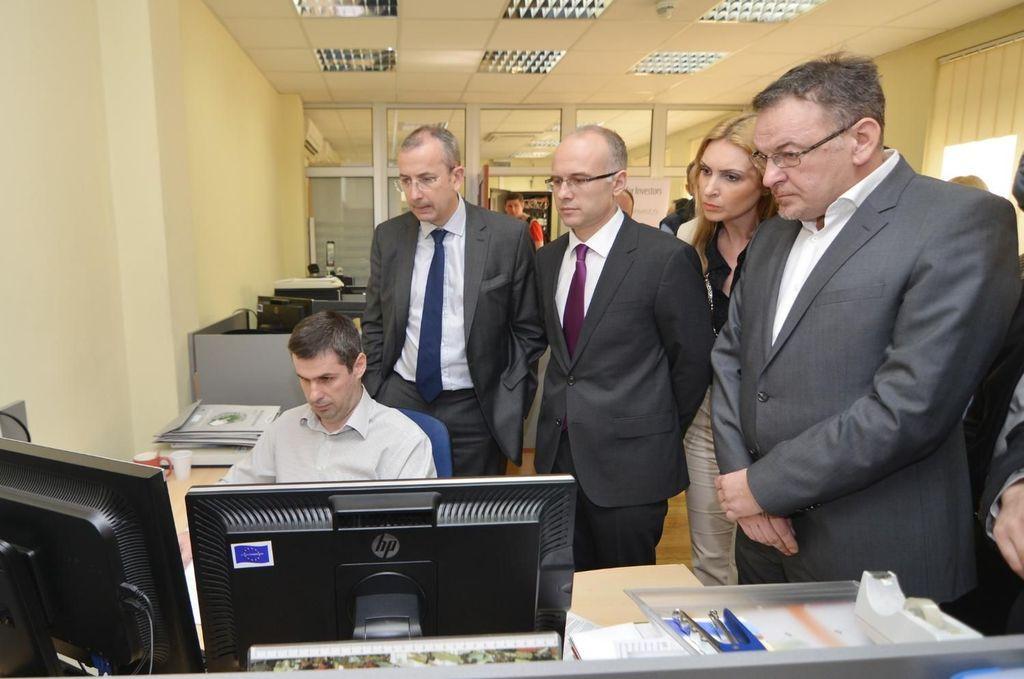In one or two sentences, can you explain what this image depicts? In this image I can see there are persons standing and one person sitting on the chair. And there is a system on the table. And there are books, bad, plastic, cups and some objects. And at the back there is a door and a wall. And there are window and curtain. And there is a cupboard. And at the top there is a ceiling with fence. 